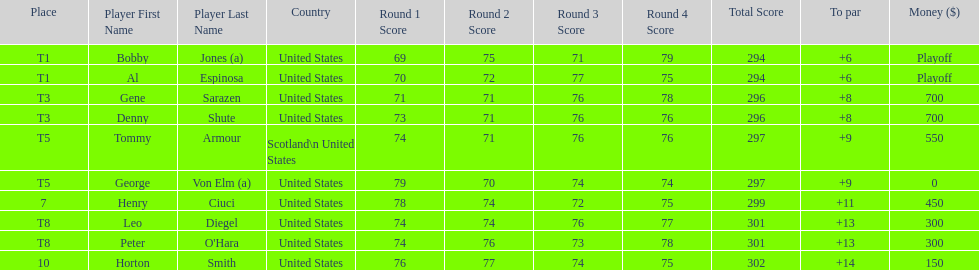Did tommy armour place above or below denny shute? Below. 